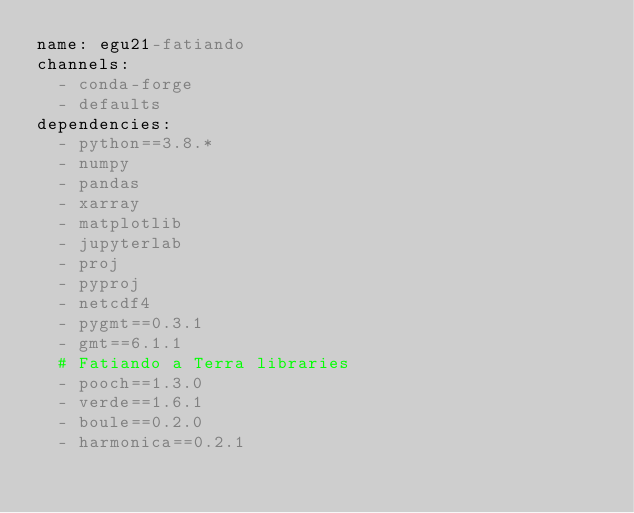<code> <loc_0><loc_0><loc_500><loc_500><_YAML_>name: egu21-fatiando
channels:
  - conda-forge
  - defaults
dependencies:
  - python==3.8.*
  - numpy
  - pandas
  - xarray
  - matplotlib
  - jupyterlab
  - proj
  - pyproj
  - netcdf4
  - pygmt==0.3.1
  - gmt==6.1.1
  # Fatiando a Terra libraries
  - pooch==1.3.0
  - verde==1.6.1
  - boule==0.2.0
  - harmonica==0.2.1
</code> 